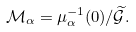Convert formula to latex. <formula><loc_0><loc_0><loc_500><loc_500>\mathcal { M } _ { \alpha } = \mu _ { \alpha } ^ { - 1 } ( 0 ) / \widetilde { \mathcal { G } } .</formula> 